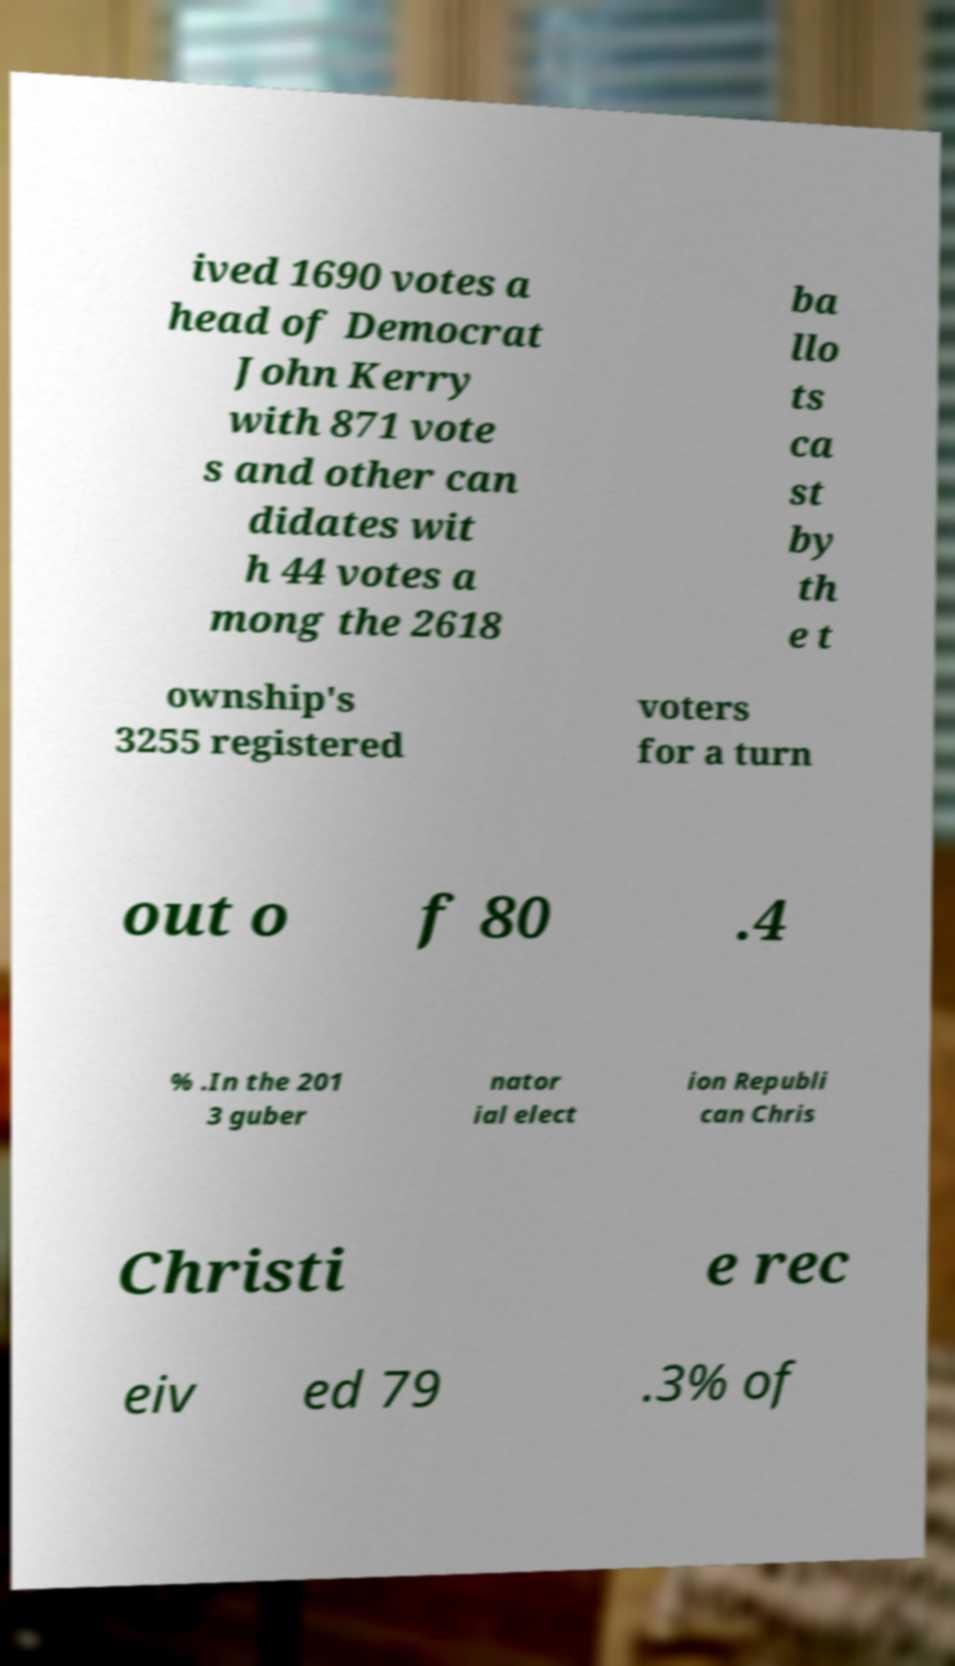I need the written content from this picture converted into text. Can you do that? ived 1690 votes a head of Democrat John Kerry with 871 vote s and other can didates wit h 44 votes a mong the 2618 ba llo ts ca st by th e t ownship's 3255 registered voters for a turn out o f 80 .4 % .In the 201 3 guber nator ial elect ion Republi can Chris Christi e rec eiv ed 79 .3% of 